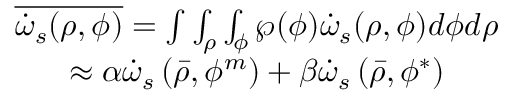Convert formula to latex. <formula><loc_0><loc_0><loc_500><loc_500>\begin{array} { c } { { { \overline { { { \dot { \omega } _ { s } ( \rho , \phi ) } } } = \int \int _ { \rho } \int _ { \phi } \wp ( \phi ) \dot { \omega } _ { s } ( \rho , \phi ) d \phi d \rho } } } \\ { { { \approx \alpha \dot { \omega } _ { s } \left ( \bar { \rho } , \phi ^ { m } \right ) + \beta \dot { \omega } _ { s } \left ( \bar { \rho } , \phi ^ { * } \right ) } } } \end{array}</formula> 